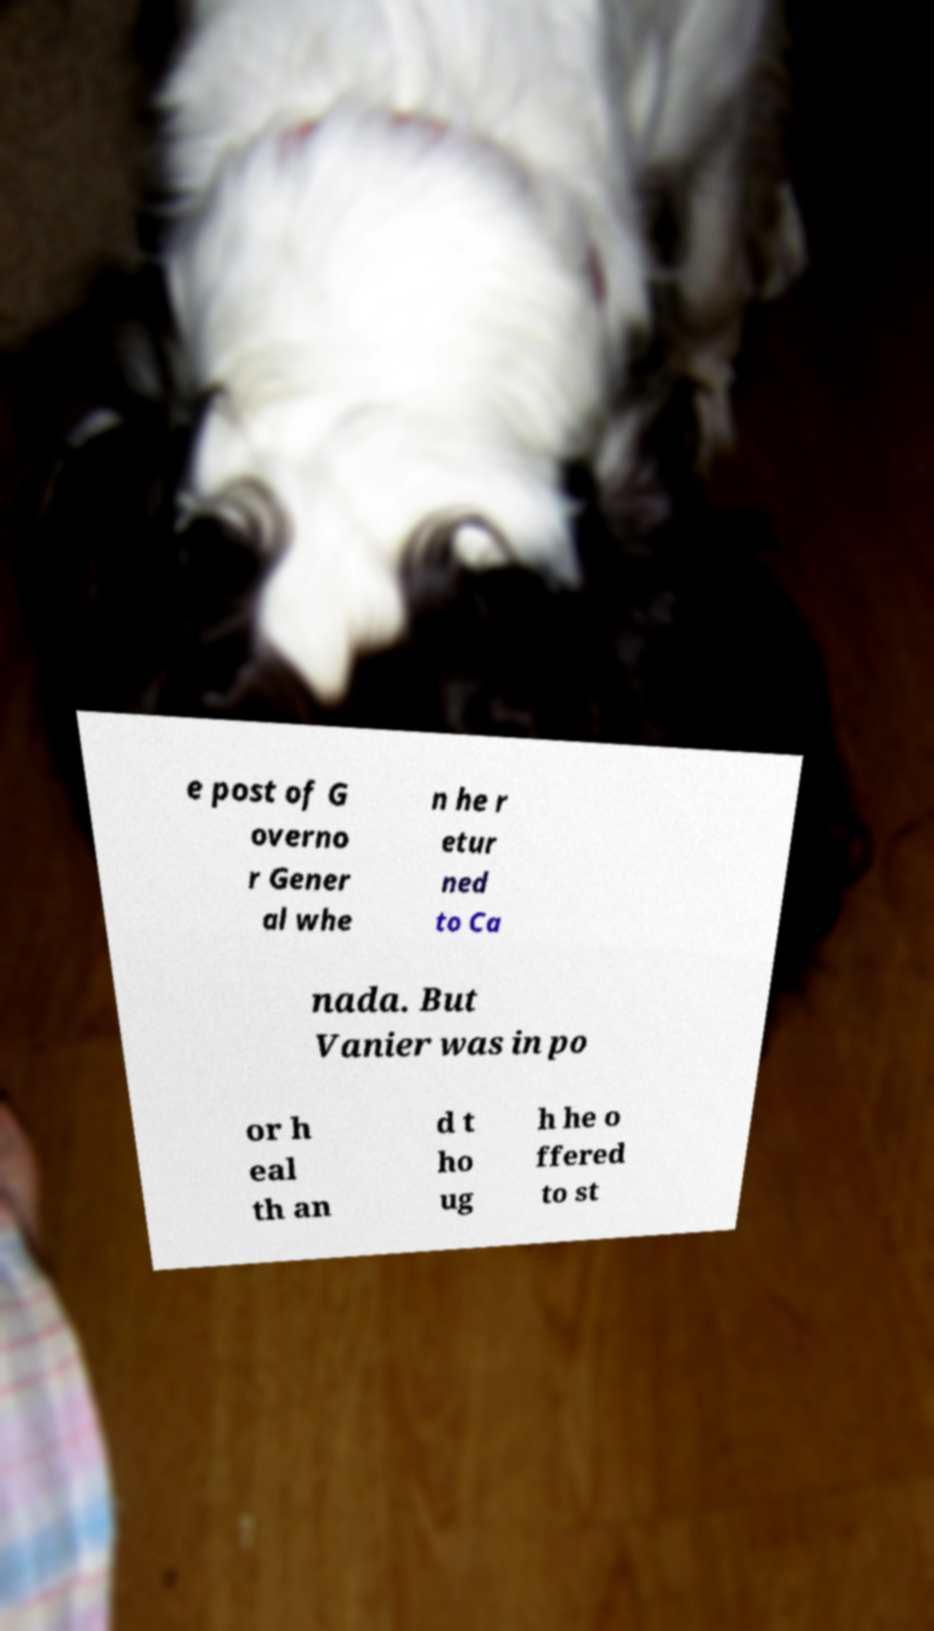Please identify and transcribe the text found in this image. e post of G overno r Gener al whe n he r etur ned to Ca nada. But Vanier was in po or h eal th an d t ho ug h he o ffered to st 